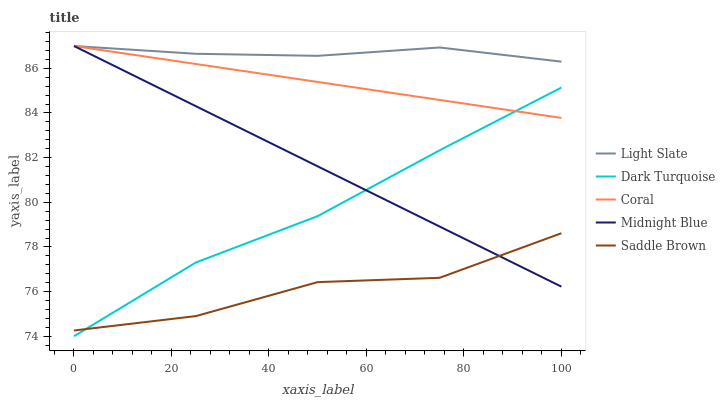Does Saddle Brown have the minimum area under the curve?
Answer yes or no. Yes. Does Light Slate have the maximum area under the curve?
Answer yes or no. Yes. Does Dark Turquoise have the minimum area under the curve?
Answer yes or no. No. Does Dark Turquoise have the maximum area under the curve?
Answer yes or no. No. Is Midnight Blue the smoothest?
Answer yes or no. Yes. Is Saddle Brown the roughest?
Answer yes or no. Yes. Is Dark Turquoise the smoothest?
Answer yes or no. No. Is Dark Turquoise the roughest?
Answer yes or no. No. Does Dark Turquoise have the lowest value?
Answer yes or no. Yes. Does Coral have the lowest value?
Answer yes or no. No. Does Midnight Blue have the highest value?
Answer yes or no. Yes. Does Dark Turquoise have the highest value?
Answer yes or no. No. Is Saddle Brown less than Coral?
Answer yes or no. Yes. Is Coral greater than Saddle Brown?
Answer yes or no. Yes. Does Midnight Blue intersect Dark Turquoise?
Answer yes or no. Yes. Is Midnight Blue less than Dark Turquoise?
Answer yes or no. No. Is Midnight Blue greater than Dark Turquoise?
Answer yes or no. No. Does Saddle Brown intersect Coral?
Answer yes or no. No. 